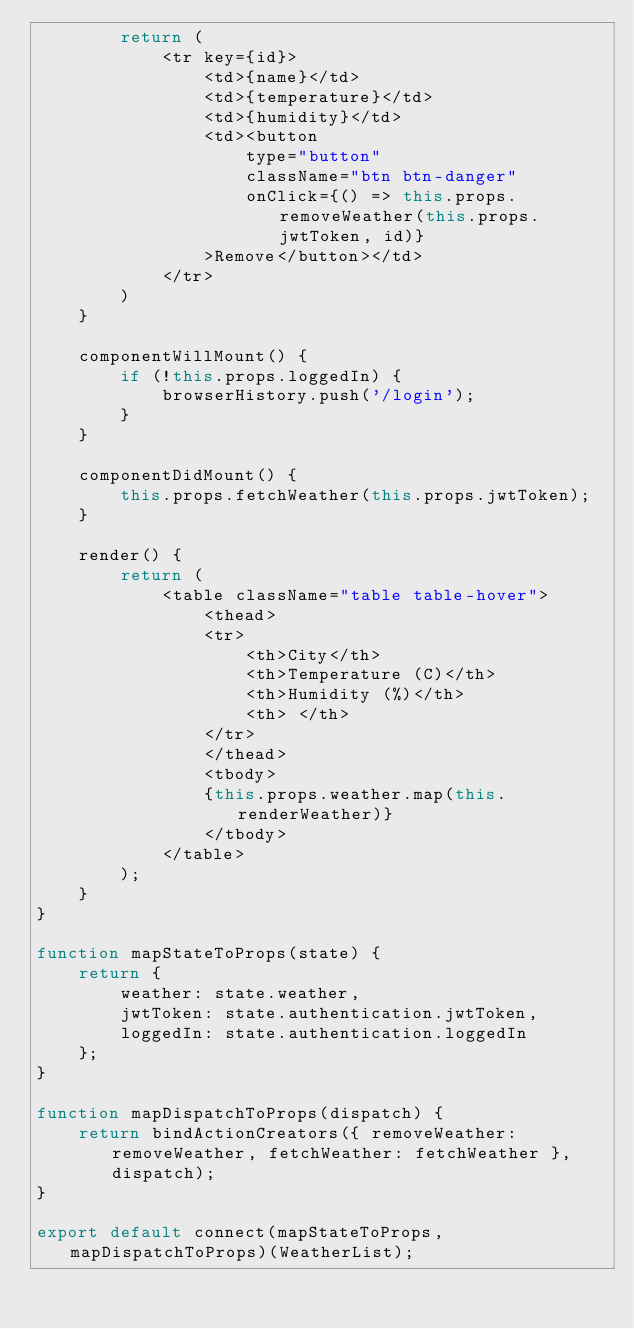<code> <loc_0><loc_0><loc_500><loc_500><_JavaScript_>        return (
            <tr key={id}>
                <td>{name}</td>
                <td>{temperature}</td>
                <td>{humidity}</td>
                <td><button
                    type="button"
                    className="btn btn-danger"
                    onClick={() => this.props.removeWeather(this.props.jwtToken, id)}
                >Remove</button></td>
            </tr>
        )
    }

    componentWillMount() {
        if (!this.props.loggedIn) {
            browserHistory.push('/login');
        }
    }

    componentDidMount() {
        this.props.fetchWeather(this.props.jwtToken);
    }

    render() {
        return (
            <table className="table table-hover">
                <thead>
                <tr>
                    <th>City</th>
                    <th>Temperature (C)</th>
                    <th>Humidity (%)</th>
                    <th> </th>
                </tr>
                </thead>
                <tbody>
                {this.props.weather.map(this.renderWeather)}
                </tbody>
            </table>
        );
    }
}

function mapStateToProps(state) {
    return {
        weather: state.weather,
        jwtToken: state.authentication.jwtToken,
        loggedIn: state.authentication.loggedIn
    };
}

function mapDispatchToProps(dispatch) {
    return bindActionCreators({ removeWeather: removeWeather, fetchWeather: fetchWeather }, dispatch);
}

export default connect(mapStateToProps, mapDispatchToProps)(WeatherList);</code> 